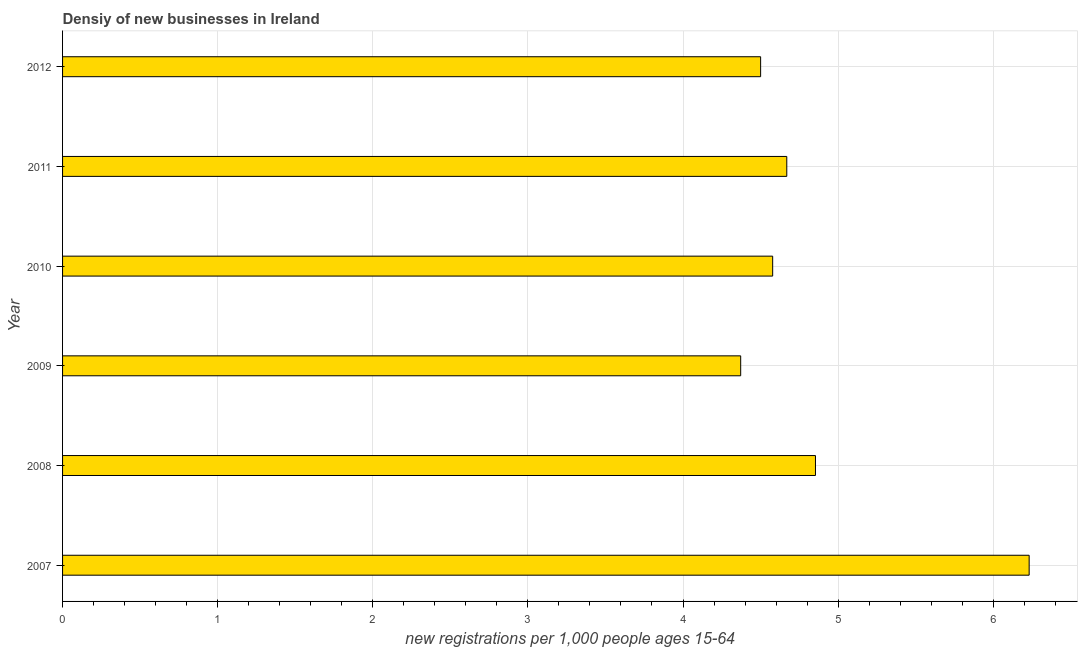Does the graph contain any zero values?
Provide a succinct answer. No. Does the graph contain grids?
Ensure brevity in your answer.  Yes. What is the title of the graph?
Your answer should be compact. Densiy of new businesses in Ireland. What is the label or title of the X-axis?
Your response must be concise. New registrations per 1,0 people ages 15-64. What is the label or title of the Y-axis?
Ensure brevity in your answer.  Year. What is the density of new business in 2012?
Offer a very short reply. 4.5. Across all years, what is the maximum density of new business?
Offer a terse response. 6.23. Across all years, what is the minimum density of new business?
Your response must be concise. 4.37. What is the sum of the density of new business?
Make the answer very short. 29.2. What is the difference between the density of new business in 2007 and 2011?
Provide a succinct answer. 1.56. What is the average density of new business per year?
Offer a terse response. 4.87. What is the median density of new business?
Provide a short and direct response. 4.62. In how many years, is the density of new business greater than 5 ?
Your response must be concise. 1. Do a majority of the years between 2011 and 2010 (inclusive) have density of new business greater than 5.4 ?
Make the answer very short. No. What is the ratio of the density of new business in 2011 to that in 2012?
Your answer should be compact. 1.04. What is the difference between the highest and the second highest density of new business?
Your response must be concise. 1.38. Is the sum of the density of new business in 2009 and 2010 greater than the maximum density of new business across all years?
Make the answer very short. Yes. What is the difference between the highest and the lowest density of new business?
Offer a very short reply. 1.86. How many years are there in the graph?
Give a very brief answer. 6. Are the values on the major ticks of X-axis written in scientific E-notation?
Make the answer very short. No. What is the new registrations per 1,000 people ages 15-64 in 2007?
Keep it short and to the point. 6.23. What is the new registrations per 1,000 people ages 15-64 in 2008?
Offer a terse response. 4.85. What is the new registrations per 1,000 people ages 15-64 in 2009?
Give a very brief answer. 4.37. What is the new registrations per 1,000 people ages 15-64 in 2010?
Offer a very short reply. 4.58. What is the new registrations per 1,000 people ages 15-64 in 2011?
Provide a succinct answer. 4.67. What is the new registrations per 1,000 people ages 15-64 in 2012?
Your answer should be very brief. 4.5. What is the difference between the new registrations per 1,000 people ages 15-64 in 2007 and 2008?
Your response must be concise. 1.38. What is the difference between the new registrations per 1,000 people ages 15-64 in 2007 and 2009?
Offer a very short reply. 1.86. What is the difference between the new registrations per 1,000 people ages 15-64 in 2007 and 2010?
Ensure brevity in your answer.  1.65. What is the difference between the new registrations per 1,000 people ages 15-64 in 2007 and 2011?
Keep it short and to the point. 1.56. What is the difference between the new registrations per 1,000 people ages 15-64 in 2007 and 2012?
Give a very brief answer. 1.73. What is the difference between the new registrations per 1,000 people ages 15-64 in 2008 and 2009?
Your response must be concise. 0.48. What is the difference between the new registrations per 1,000 people ages 15-64 in 2008 and 2010?
Offer a very short reply. 0.28. What is the difference between the new registrations per 1,000 people ages 15-64 in 2008 and 2011?
Your answer should be compact. 0.19. What is the difference between the new registrations per 1,000 people ages 15-64 in 2008 and 2012?
Offer a very short reply. 0.35. What is the difference between the new registrations per 1,000 people ages 15-64 in 2009 and 2010?
Give a very brief answer. -0.21. What is the difference between the new registrations per 1,000 people ages 15-64 in 2009 and 2011?
Provide a short and direct response. -0.3. What is the difference between the new registrations per 1,000 people ages 15-64 in 2009 and 2012?
Provide a succinct answer. -0.13. What is the difference between the new registrations per 1,000 people ages 15-64 in 2010 and 2011?
Keep it short and to the point. -0.09. What is the difference between the new registrations per 1,000 people ages 15-64 in 2010 and 2012?
Make the answer very short. 0.08. What is the difference between the new registrations per 1,000 people ages 15-64 in 2011 and 2012?
Provide a succinct answer. 0.17. What is the ratio of the new registrations per 1,000 people ages 15-64 in 2007 to that in 2008?
Your response must be concise. 1.28. What is the ratio of the new registrations per 1,000 people ages 15-64 in 2007 to that in 2009?
Provide a succinct answer. 1.43. What is the ratio of the new registrations per 1,000 people ages 15-64 in 2007 to that in 2010?
Make the answer very short. 1.36. What is the ratio of the new registrations per 1,000 people ages 15-64 in 2007 to that in 2011?
Give a very brief answer. 1.33. What is the ratio of the new registrations per 1,000 people ages 15-64 in 2007 to that in 2012?
Offer a terse response. 1.39. What is the ratio of the new registrations per 1,000 people ages 15-64 in 2008 to that in 2009?
Your answer should be compact. 1.11. What is the ratio of the new registrations per 1,000 people ages 15-64 in 2008 to that in 2010?
Your answer should be compact. 1.06. What is the ratio of the new registrations per 1,000 people ages 15-64 in 2008 to that in 2011?
Keep it short and to the point. 1.04. What is the ratio of the new registrations per 1,000 people ages 15-64 in 2008 to that in 2012?
Ensure brevity in your answer.  1.08. What is the ratio of the new registrations per 1,000 people ages 15-64 in 2009 to that in 2010?
Offer a very short reply. 0.95. What is the ratio of the new registrations per 1,000 people ages 15-64 in 2009 to that in 2011?
Offer a very short reply. 0.94. 